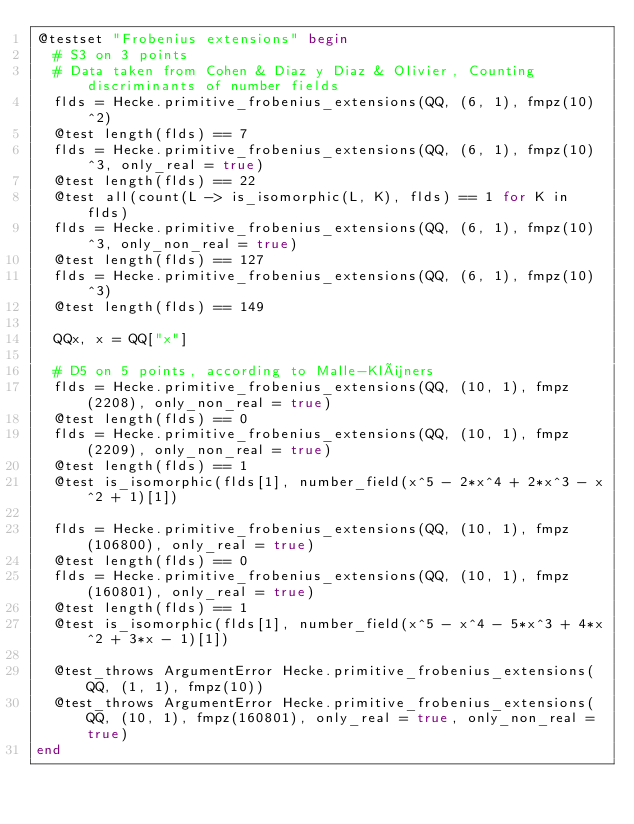<code> <loc_0><loc_0><loc_500><loc_500><_Julia_>@testset "Frobenius extensions" begin
  # S3 on 3 points
  # Data taken from Cohen & Diaz y Diaz & Olivier, Counting discriminants of number fields
  flds = Hecke.primitive_frobenius_extensions(QQ, (6, 1), fmpz(10)^2)
  @test length(flds) == 7
  flds = Hecke.primitive_frobenius_extensions(QQ, (6, 1), fmpz(10)^3, only_real = true)
  @test length(flds) == 22
  @test all(count(L -> is_isomorphic(L, K), flds) == 1 for K in flds)
  flds = Hecke.primitive_frobenius_extensions(QQ, (6, 1), fmpz(10)^3, only_non_real = true)
  @test length(flds) == 127
  flds = Hecke.primitive_frobenius_extensions(QQ, (6, 1), fmpz(10)^3)
  @test length(flds) == 149

  QQx, x = QQ["x"]

  # D5 on 5 points, according to Malle-Klüners
  flds = Hecke.primitive_frobenius_extensions(QQ, (10, 1), fmpz(2208), only_non_real = true)
  @test length(flds) == 0
  flds = Hecke.primitive_frobenius_extensions(QQ, (10, 1), fmpz(2209), only_non_real = true)
  @test length(flds) == 1
  @test is_isomorphic(flds[1], number_field(x^5 - 2*x^4 + 2*x^3 - x^2 + 1)[1])

  flds = Hecke.primitive_frobenius_extensions(QQ, (10, 1), fmpz(106800), only_real = true)
  @test length(flds) == 0
  flds = Hecke.primitive_frobenius_extensions(QQ, (10, 1), fmpz(160801), only_real = true)
  @test length(flds) == 1
  @test is_isomorphic(flds[1], number_field(x^5 - x^4 - 5*x^3 + 4*x^2 + 3*x - 1)[1])

  @test_throws ArgumentError Hecke.primitive_frobenius_extensions(QQ, (1, 1), fmpz(10))
  @test_throws ArgumentError Hecke.primitive_frobenius_extensions(QQ, (10, 1), fmpz(160801), only_real = true, only_non_real = true)
end
</code> 